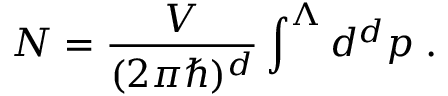Convert formula to latex. <formula><loc_0><loc_0><loc_500><loc_500>N = \frac { V } { ( 2 \pi \hbar { ) } ^ { d } } \int ^ { \Lambda } d ^ { d } p \, .</formula> 